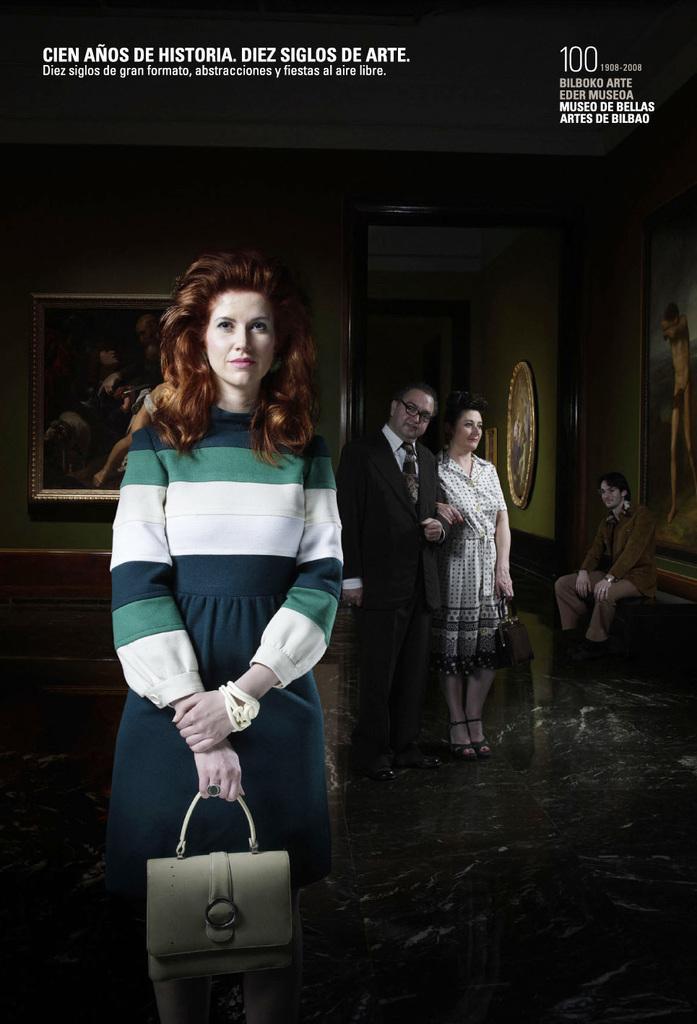Please provide a concise description of this image. In this picture we can see few people, on the left side of the image we can find a woman, she is holding a bag, in the background we can find few paintings on the walls. 